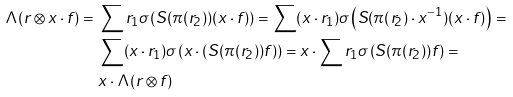Convert formula to latex. <formula><loc_0><loc_0><loc_500><loc_500>\Lambda ( r \otimes x \cdot f ) = & \ \sum r _ { 1 } \sigma \left ( S ( \pi ( r _ { 2 } ) ) ( x \cdot f ) \right ) = \sum ( x \cdot r _ { 1 } ) \sigma \left ( S ( \pi ( r _ { 2 } ) \cdot x ^ { - 1 } ) ( x \cdot f ) \right ) = \\ & \ \sum ( x \cdot r _ { 1 } ) \sigma \left ( x \cdot \left ( S ( \pi ( r _ { 2 } ) ) f \right ) \right ) = x \cdot \sum r _ { 1 } \sigma \left ( S ( \pi ( r _ { 2 } ) ) f \right ) = \\ & \ x \cdot \Lambda ( r \otimes f )</formula> 